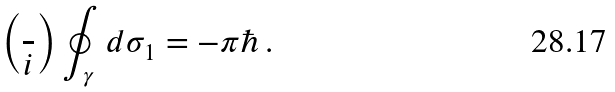<formula> <loc_0><loc_0><loc_500><loc_500>\left ( \frac { } { i } \right ) \oint _ { \gamma } \, d \sigma _ { 1 } = - \pi \hbar { \, } .</formula> 